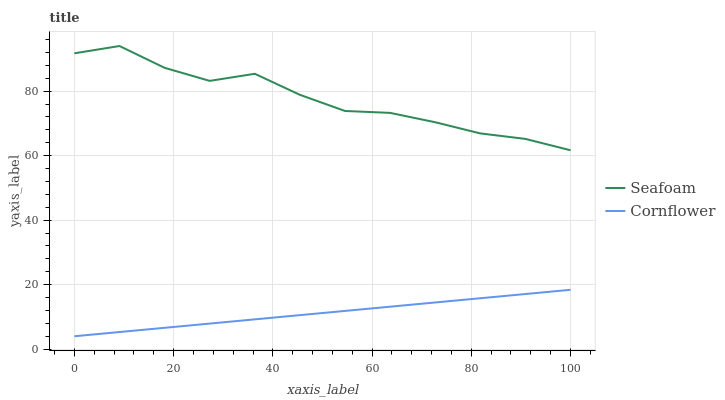Does Cornflower have the minimum area under the curve?
Answer yes or no. Yes. Does Seafoam have the maximum area under the curve?
Answer yes or no. Yes. Does Seafoam have the minimum area under the curve?
Answer yes or no. No. Is Cornflower the smoothest?
Answer yes or no. Yes. Is Seafoam the roughest?
Answer yes or no. Yes. Is Seafoam the smoothest?
Answer yes or no. No. Does Cornflower have the lowest value?
Answer yes or no. Yes. Does Seafoam have the lowest value?
Answer yes or no. No. Does Seafoam have the highest value?
Answer yes or no. Yes. Is Cornflower less than Seafoam?
Answer yes or no. Yes. Is Seafoam greater than Cornflower?
Answer yes or no. Yes. Does Cornflower intersect Seafoam?
Answer yes or no. No. 